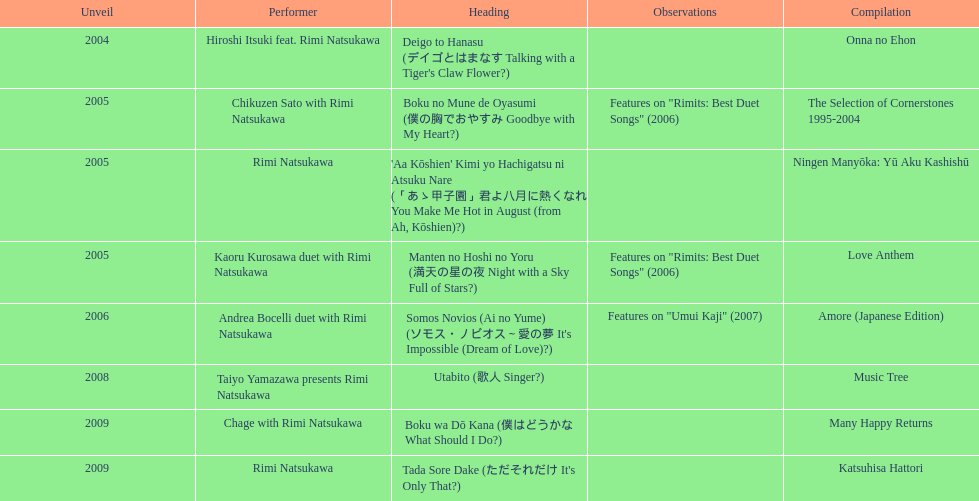What year was onna no ehon released? 2004. What year was music tree released? 2008. Which of the two was not released in 2004? Music Tree. 